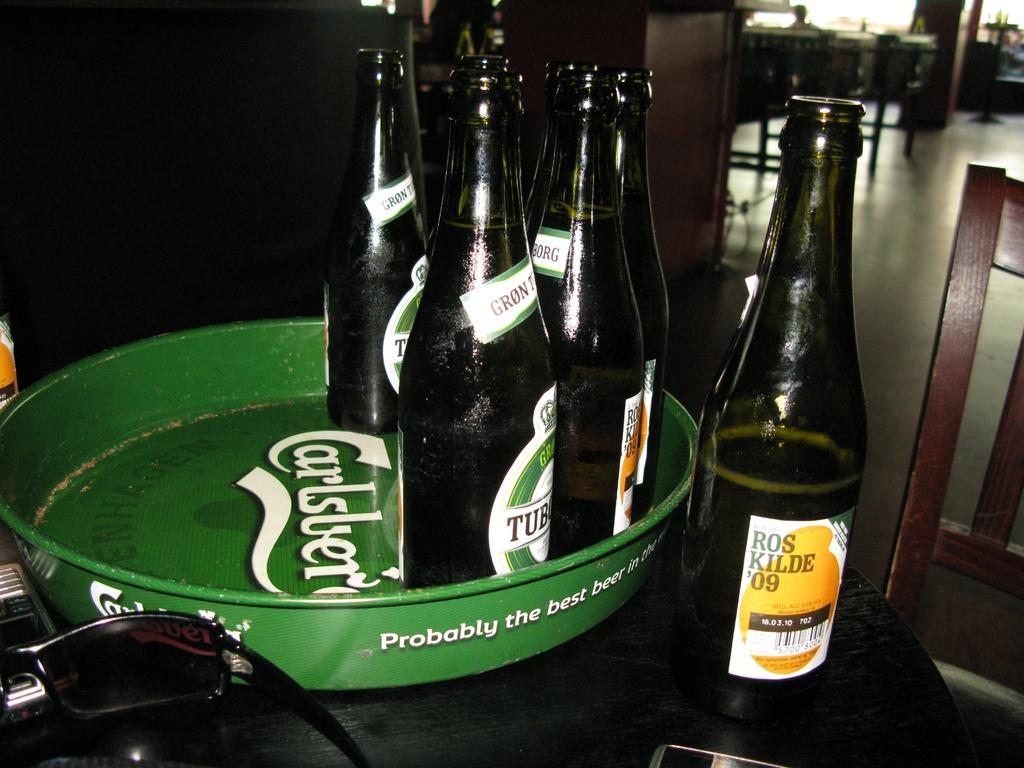Provide a one-sentence caption for the provided image. A bottle of Ros Kilde 09 next to a tray with bottles on it. 